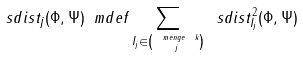<formula> <loc_0><loc_0><loc_500><loc_500>\ s d i s t _ { j } ( \Phi , \Psi ) \ m d e f \sum _ { I _ { j } \in \binom { \ m e n g e { \ k } } { j } } \ s d i s t ^ { 2 } _ { I _ { j } } ( \Phi , \Psi )</formula> 